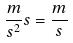<formula> <loc_0><loc_0><loc_500><loc_500>\frac { m } { s ^ { 2 } } s = \frac { m } { s }</formula> 